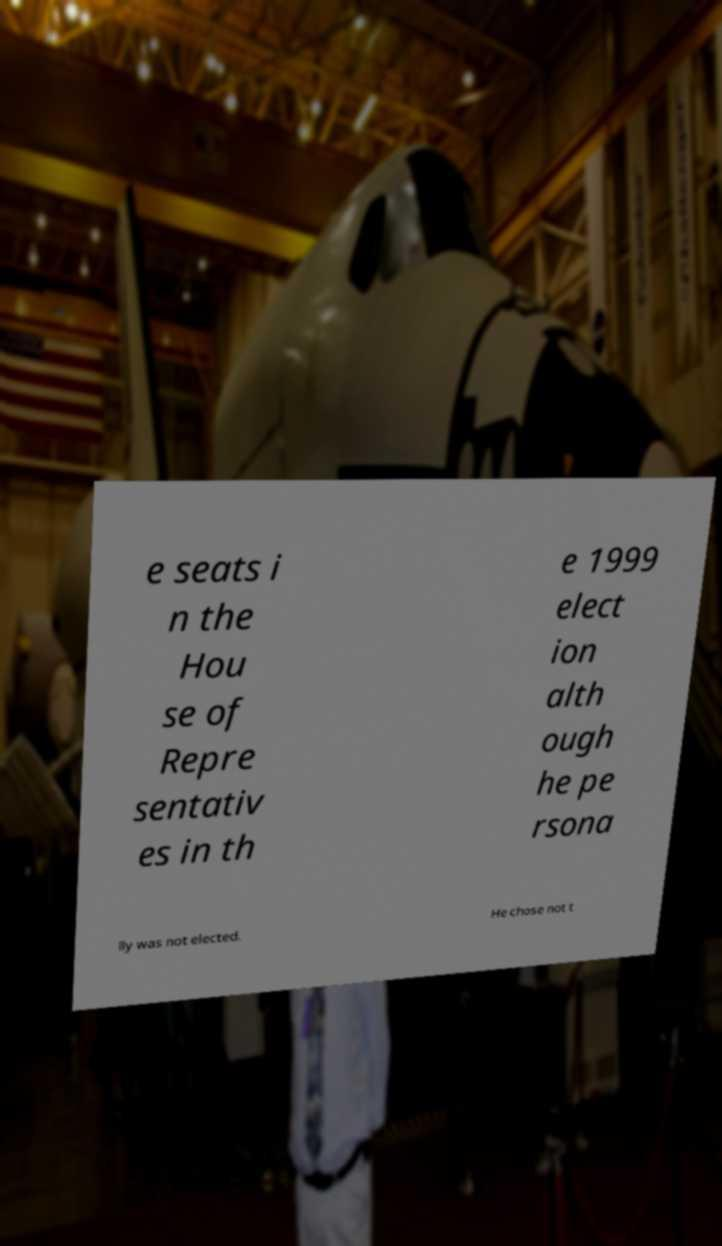Please identify and transcribe the text found in this image. e seats i n the Hou se of Repre sentativ es in th e 1999 elect ion alth ough he pe rsona lly was not elected. He chose not t 